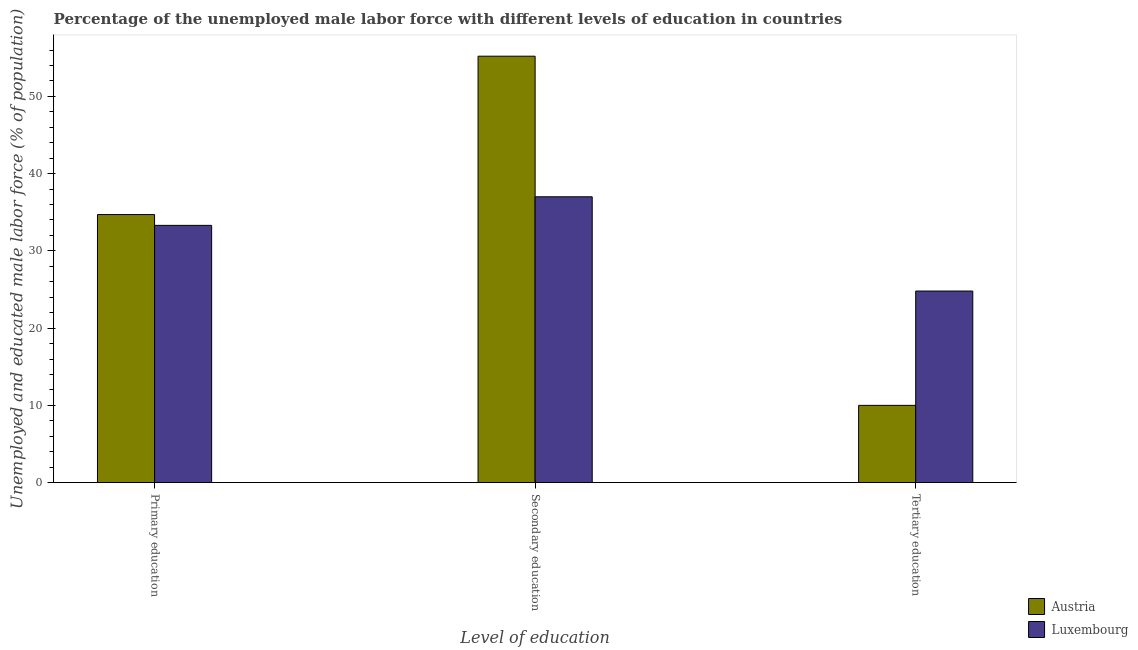How many groups of bars are there?
Make the answer very short. 3. Are the number of bars on each tick of the X-axis equal?
Your answer should be compact. Yes. How many bars are there on the 3rd tick from the left?
Ensure brevity in your answer.  2. How many bars are there on the 3rd tick from the right?
Provide a short and direct response. 2. What is the label of the 2nd group of bars from the left?
Offer a terse response. Secondary education. What is the percentage of male labor force who received tertiary education in Austria?
Keep it short and to the point. 10. Across all countries, what is the maximum percentage of male labor force who received tertiary education?
Give a very brief answer. 24.8. Across all countries, what is the minimum percentage of male labor force who received primary education?
Provide a short and direct response. 33.3. In which country was the percentage of male labor force who received secondary education minimum?
Your answer should be very brief. Luxembourg. What is the total percentage of male labor force who received secondary education in the graph?
Give a very brief answer. 92.2. What is the difference between the percentage of male labor force who received tertiary education in Austria and that in Luxembourg?
Your response must be concise. -14.8. What is the difference between the percentage of male labor force who received secondary education in Luxembourg and the percentage of male labor force who received tertiary education in Austria?
Your answer should be compact. 27. What is the average percentage of male labor force who received tertiary education per country?
Ensure brevity in your answer.  17.4. What is the difference between the percentage of male labor force who received primary education and percentage of male labor force who received tertiary education in Austria?
Offer a very short reply. 24.7. What is the ratio of the percentage of male labor force who received tertiary education in Luxembourg to that in Austria?
Ensure brevity in your answer.  2.48. What is the difference between the highest and the second highest percentage of male labor force who received secondary education?
Offer a terse response. 18.2. What is the difference between the highest and the lowest percentage of male labor force who received primary education?
Provide a succinct answer. 1.4. In how many countries, is the percentage of male labor force who received primary education greater than the average percentage of male labor force who received primary education taken over all countries?
Your answer should be very brief. 1. Is the sum of the percentage of male labor force who received secondary education in Austria and Luxembourg greater than the maximum percentage of male labor force who received tertiary education across all countries?
Your response must be concise. Yes. How many bars are there?
Make the answer very short. 6. Are all the bars in the graph horizontal?
Keep it short and to the point. No. How many countries are there in the graph?
Make the answer very short. 2. What is the difference between two consecutive major ticks on the Y-axis?
Your answer should be very brief. 10. Does the graph contain any zero values?
Your answer should be very brief. No. How many legend labels are there?
Keep it short and to the point. 2. How are the legend labels stacked?
Ensure brevity in your answer.  Vertical. What is the title of the graph?
Provide a short and direct response. Percentage of the unemployed male labor force with different levels of education in countries. Does "Chad" appear as one of the legend labels in the graph?
Your answer should be very brief. No. What is the label or title of the X-axis?
Ensure brevity in your answer.  Level of education. What is the label or title of the Y-axis?
Ensure brevity in your answer.  Unemployed and educated male labor force (% of population). What is the Unemployed and educated male labor force (% of population) of Austria in Primary education?
Your response must be concise. 34.7. What is the Unemployed and educated male labor force (% of population) in Luxembourg in Primary education?
Your response must be concise. 33.3. What is the Unemployed and educated male labor force (% of population) of Austria in Secondary education?
Your answer should be compact. 55.2. What is the Unemployed and educated male labor force (% of population) of Luxembourg in Secondary education?
Keep it short and to the point. 37. What is the Unemployed and educated male labor force (% of population) in Luxembourg in Tertiary education?
Ensure brevity in your answer.  24.8. Across all Level of education, what is the maximum Unemployed and educated male labor force (% of population) of Austria?
Your answer should be compact. 55.2. Across all Level of education, what is the maximum Unemployed and educated male labor force (% of population) in Luxembourg?
Provide a succinct answer. 37. Across all Level of education, what is the minimum Unemployed and educated male labor force (% of population) of Austria?
Keep it short and to the point. 10. Across all Level of education, what is the minimum Unemployed and educated male labor force (% of population) in Luxembourg?
Your response must be concise. 24.8. What is the total Unemployed and educated male labor force (% of population) in Austria in the graph?
Give a very brief answer. 99.9. What is the total Unemployed and educated male labor force (% of population) in Luxembourg in the graph?
Your response must be concise. 95.1. What is the difference between the Unemployed and educated male labor force (% of population) of Austria in Primary education and that in Secondary education?
Offer a very short reply. -20.5. What is the difference between the Unemployed and educated male labor force (% of population) in Austria in Primary education and that in Tertiary education?
Offer a terse response. 24.7. What is the difference between the Unemployed and educated male labor force (% of population) of Luxembourg in Primary education and that in Tertiary education?
Give a very brief answer. 8.5. What is the difference between the Unemployed and educated male labor force (% of population) in Austria in Secondary education and that in Tertiary education?
Your response must be concise. 45.2. What is the difference between the Unemployed and educated male labor force (% of population) of Austria in Primary education and the Unemployed and educated male labor force (% of population) of Luxembourg in Secondary education?
Offer a very short reply. -2.3. What is the difference between the Unemployed and educated male labor force (% of population) in Austria in Primary education and the Unemployed and educated male labor force (% of population) in Luxembourg in Tertiary education?
Provide a short and direct response. 9.9. What is the difference between the Unemployed and educated male labor force (% of population) in Austria in Secondary education and the Unemployed and educated male labor force (% of population) in Luxembourg in Tertiary education?
Keep it short and to the point. 30.4. What is the average Unemployed and educated male labor force (% of population) in Austria per Level of education?
Ensure brevity in your answer.  33.3. What is the average Unemployed and educated male labor force (% of population) in Luxembourg per Level of education?
Provide a succinct answer. 31.7. What is the difference between the Unemployed and educated male labor force (% of population) in Austria and Unemployed and educated male labor force (% of population) in Luxembourg in Tertiary education?
Give a very brief answer. -14.8. What is the ratio of the Unemployed and educated male labor force (% of population) in Austria in Primary education to that in Secondary education?
Provide a short and direct response. 0.63. What is the ratio of the Unemployed and educated male labor force (% of population) of Luxembourg in Primary education to that in Secondary education?
Provide a short and direct response. 0.9. What is the ratio of the Unemployed and educated male labor force (% of population) in Austria in Primary education to that in Tertiary education?
Ensure brevity in your answer.  3.47. What is the ratio of the Unemployed and educated male labor force (% of population) in Luxembourg in Primary education to that in Tertiary education?
Ensure brevity in your answer.  1.34. What is the ratio of the Unemployed and educated male labor force (% of population) of Austria in Secondary education to that in Tertiary education?
Your response must be concise. 5.52. What is the ratio of the Unemployed and educated male labor force (% of population) of Luxembourg in Secondary education to that in Tertiary education?
Ensure brevity in your answer.  1.49. What is the difference between the highest and the second highest Unemployed and educated male labor force (% of population) in Austria?
Offer a terse response. 20.5. What is the difference between the highest and the lowest Unemployed and educated male labor force (% of population) in Austria?
Provide a succinct answer. 45.2. What is the difference between the highest and the lowest Unemployed and educated male labor force (% of population) in Luxembourg?
Provide a succinct answer. 12.2. 